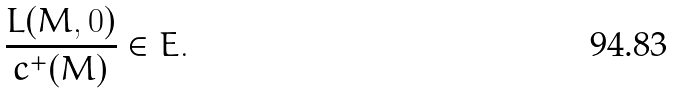Convert formula to latex. <formula><loc_0><loc_0><loc_500><loc_500>\frac { L ( M , 0 ) } { c ^ { + } ( M ) } \in E .</formula> 